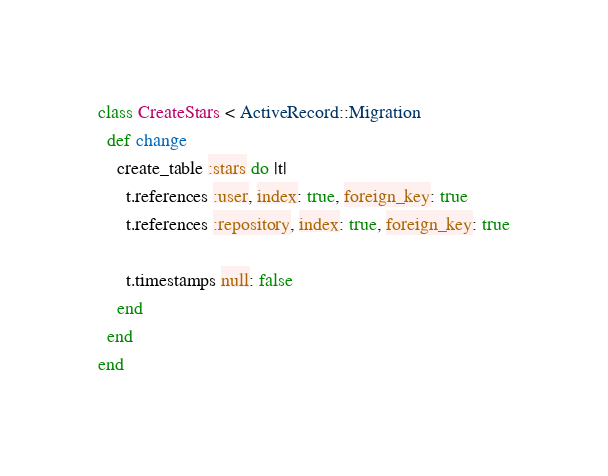Convert code to text. <code><loc_0><loc_0><loc_500><loc_500><_Ruby_>class CreateStars < ActiveRecord::Migration
  def change
    create_table :stars do |t|
      t.references :user, index: true, foreign_key: true
      t.references :repository, index: true, foreign_key: true
      
      t.timestamps null: false
    end
  end
end
</code> 